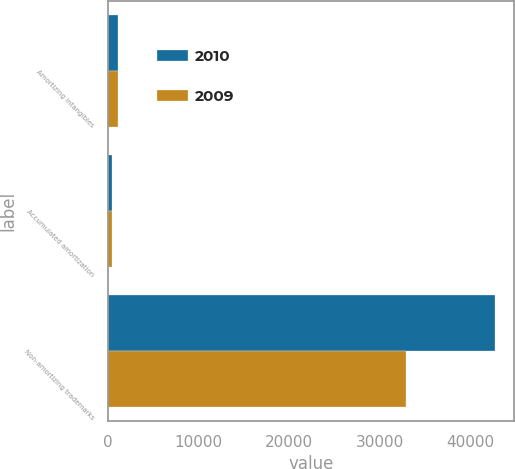Convert chart. <chart><loc_0><loc_0><loc_500><loc_500><stacked_bar_chart><ecel><fcel>Amortizing intangibles<fcel>Accumulated amortization<fcel>Non-amortizing trademarks<nl><fcel>2010<fcel>1047<fcel>452<fcel>42721<nl><fcel>2009<fcel>1073<fcel>414<fcel>32853<nl></chart> 